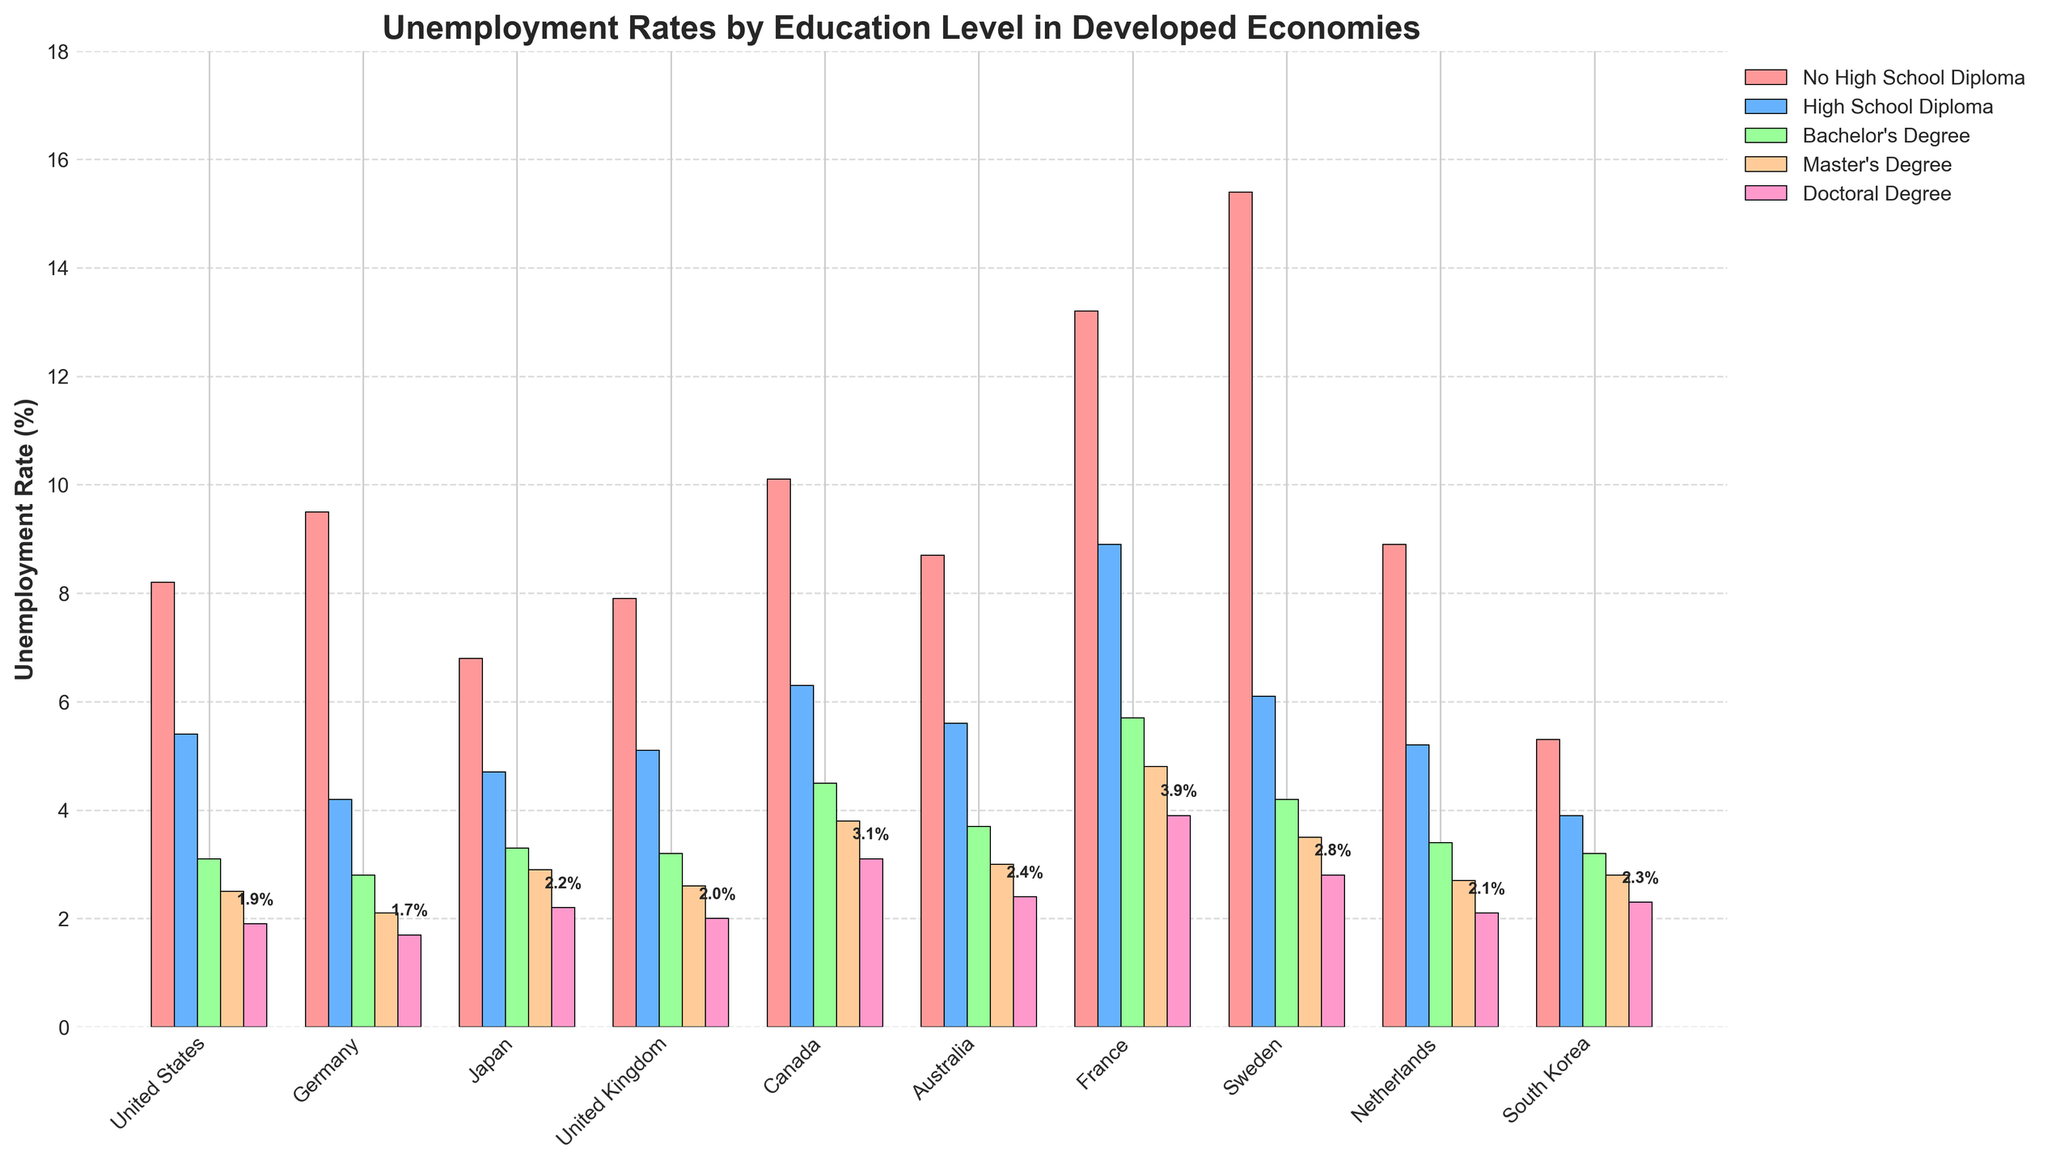What is the unemployment rate for people with a Bachelor's degree in Canada, and how does it compare with those holding a Master's degree in Canada? To find the unemployment rates for people with a Bachelor's degree and those with a Master's degree in Canada, refer to the relevant bars. The Bachelor's degree bar shows an unemployment rate of 4.5%, and the Master's degree bar shows 3.8%. The difference is 4.5% - 3.8% = 0.7%.
Answer: The unemployment rate for people with a Bachelor's degree in Canada is 4.5%, which is 0.7% higher than those with a Master's degree Which country has the highest unemployment rate for individuals without a high school diploma? To find the country with the highest unemployment rate for individuals without a high school diploma, compare the heights of the corresponding bars. The bar for France is the tallest in this category, indicating the highest unemployment rate at 13.2%.
Answer: France What is the average unemployment rate for people with a High School Diploma across all countries? Calculate the sum of the unemployment rates for people with a High School Diploma across all countries and then divide by the number of countries. The rates are 5.4, 4.2, 4.7, 5.1, 6.3, 5.6, 8.9, 6.1, 5.2, 3.9. Summing these values gives 55.4, and dividing by 10 (number of countries) gives an average of 5.54%.
Answer: 5.54% Which education level consistently shows the lowest unemployment rates across most countries? By comparing the heights of the bars for each education level across all countries, it is evident that Doctoral Degree bars are the shortest across most countries. This indicates that the Doctoral Degree level consistently shows the lowest unemployment rates.
Answer: Doctoral Degree How does the unemployment rate for Master's degree holders in Sweden compare to those in Germany? Refer to the bars representing unemployment rates for Master's degree holders in both Sweden and Germany. The rate in Sweden is 3.5%, while in Germany it is 2.1%, making it higher in Sweden by 3.5% - 2.1% = 1.4%.
Answer: The rate is 1.4% higher in Sweden What is the difference in unemployment rate between individuals with No High School Diploma and those with a Doctoral Degree in Japan? Look at the bars for Japan. The unemployment rate for individuals with No High School Diploma is 6.8%, and for those with a Doctoral Degree, it is 2.2%. The difference is 6.8% - 2.2% = 4.6%.
Answer: 4.6% In which country is the unemployment rate for High School Diploma holders closest to 5%? Compare the unemployment rates for High School Diploma holders across each country to see which is closest to 5%. The United Kingdom has a rate of 5.1%, the United States has 5.4%, and Australia has 5.6%. The United Kingdom at 5.1% is the closest to 5%.
Answer: United Kingdom By how much does the unemployment rate decrease on average for each higher level of education across all countries? To calculate, first find the difference for each country for every education level and average them: 
- US: (8.2-5.4)+(5.4-3.1)+(3.1-2.5)+(2.5-1.9) = 2.8, 2.3, 0.6, 0.6; avg = 1.58
- ... (repeat for all countries)
Sum the average differences and divide by the number of countries, which concludes approximately around 1.6% decrease per level.
Answer: Approximately 1.6% 